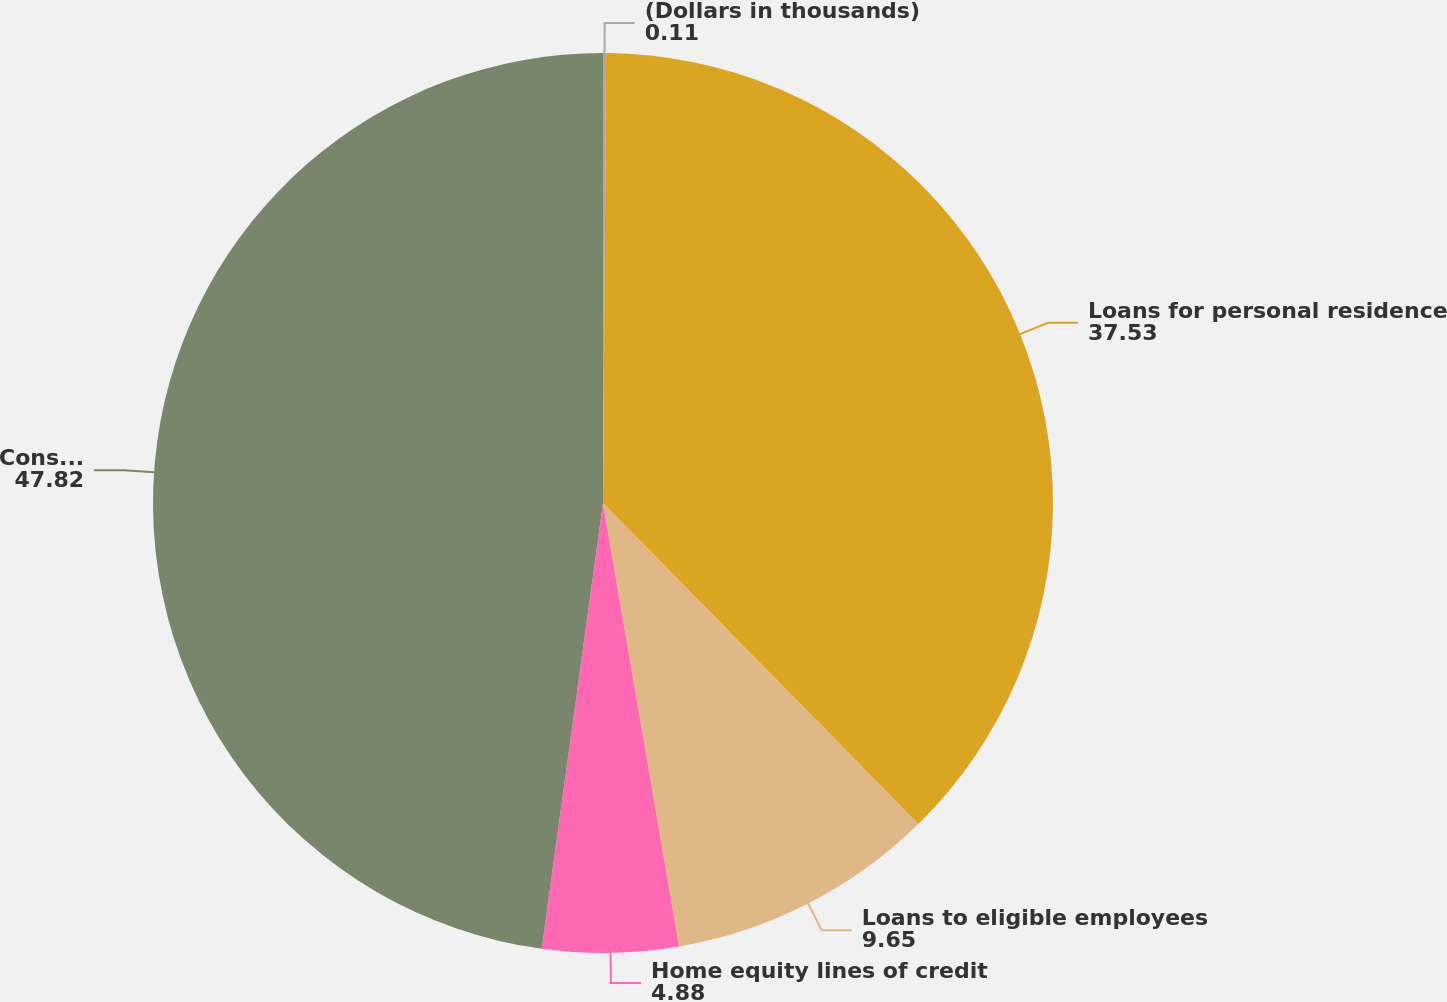Convert chart. <chart><loc_0><loc_0><loc_500><loc_500><pie_chart><fcel>(Dollars in thousands)<fcel>Loans for personal residence<fcel>Loans to eligible employees<fcel>Home equity lines of credit<fcel>Consumer loans secured by real<nl><fcel>0.11%<fcel>37.53%<fcel>9.65%<fcel>4.88%<fcel>47.82%<nl></chart> 